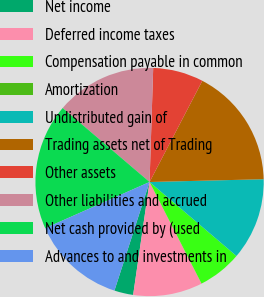<chart> <loc_0><loc_0><loc_500><loc_500><pie_chart><fcel>Net income<fcel>Deferred income taxes<fcel>Compensation payable in common<fcel>Amortization<fcel>Undistributed gain of<fcel>Trading assets net of Trading<fcel>Other assets<fcel>Other liabilities and accrued<fcel>Net cash provided by (used<fcel>Advances to and investments in<nl><fcel>2.68%<fcel>9.82%<fcel>6.25%<fcel>0.0%<fcel>11.61%<fcel>16.96%<fcel>7.14%<fcel>14.28%<fcel>17.85%<fcel>13.39%<nl></chart> 